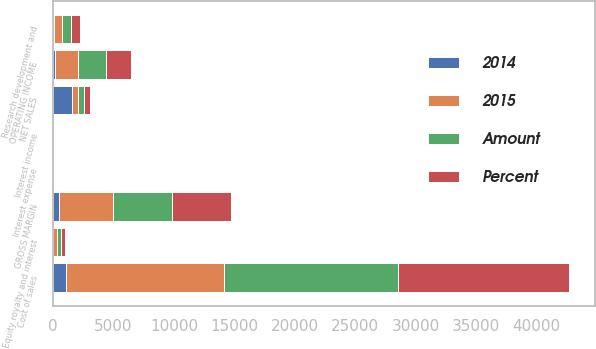Convert chart. <chart><loc_0><loc_0><loc_500><loc_500><stacked_bar_chart><ecel><fcel>NET SALES<fcel>Cost of sales<fcel>GROSS MARGIN<fcel>Research development and<fcel>Equity royalty and interest<fcel>OPERATING INCOME<fcel>Interest income<fcel>Interest expense<nl><fcel>2015<fcel>495<fcel>13057<fcel>4452<fcel>636<fcel>301<fcel>1928<fcel>23<fcel>69<nl><fcel>Percent<fcel>495<fcel>14163<fcel>4947<fcel>735<fcel>315<fcel>2057<fcel>24<fcel>65<nl><fcel>Amount<fcel>495<fcel>14360<fcel>4861<fcel>754<fcel>370<fcel>2365<fcel>23<fcel>64<nl><fcel>2014<fcel>1601<fcel>1106<fcel>495<fcel>99<fcel>14<fcel>129<fcel>1<fcel>4<nl></chart> 